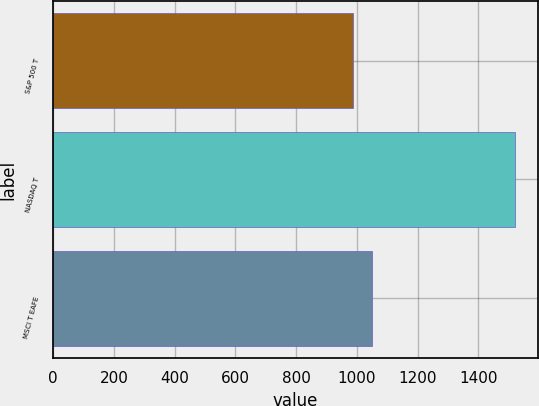Convert chart to OTSL. <chart><loc_0><loc_0><loc_500><loc_500><bar_chart><fcel>S&P 500 T<fcel>NASDAQ T<fcel>MSCI T EAFE<nl><fcel>988.6<fcel>1519.8<fcel>1050.2<nl></chart> 